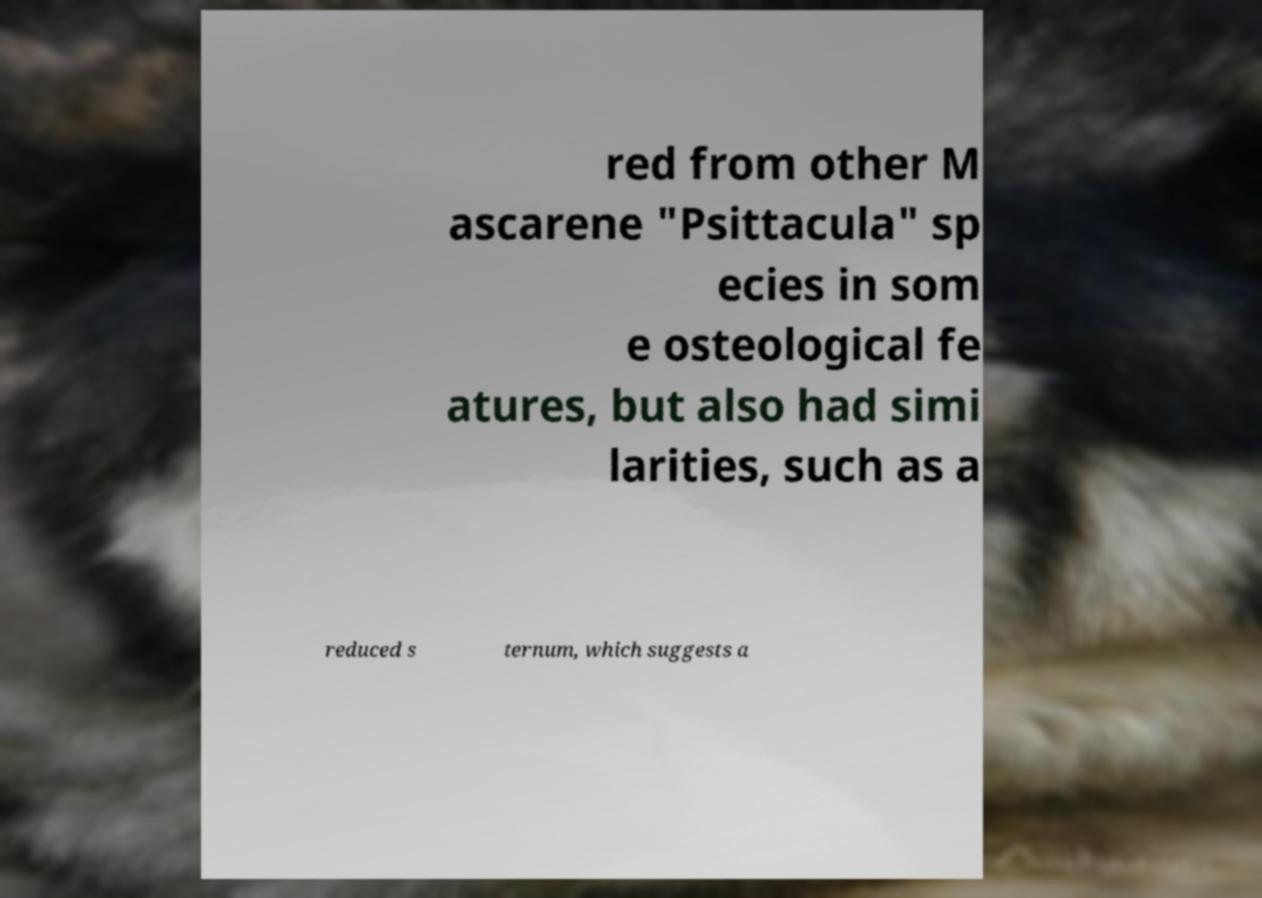There's text embedded in this image that I need extracted. Can you transcribe it verbatim? red from other M ascarene "Psittacula" sp ecies in som e osteological fe atures, but also had simi larities, such as a reduced s ternum, which suggests a 